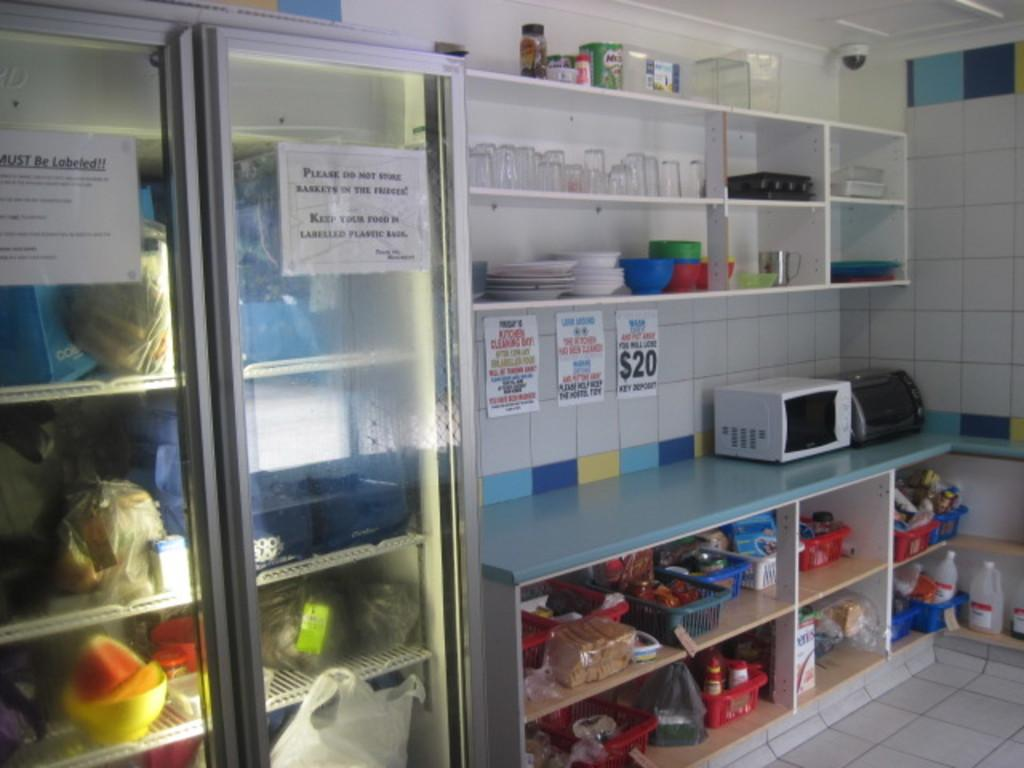<image>
Give a short and clear explanation of the subsequent image. Two signs on some fridges tell people to keep their food labelled. 